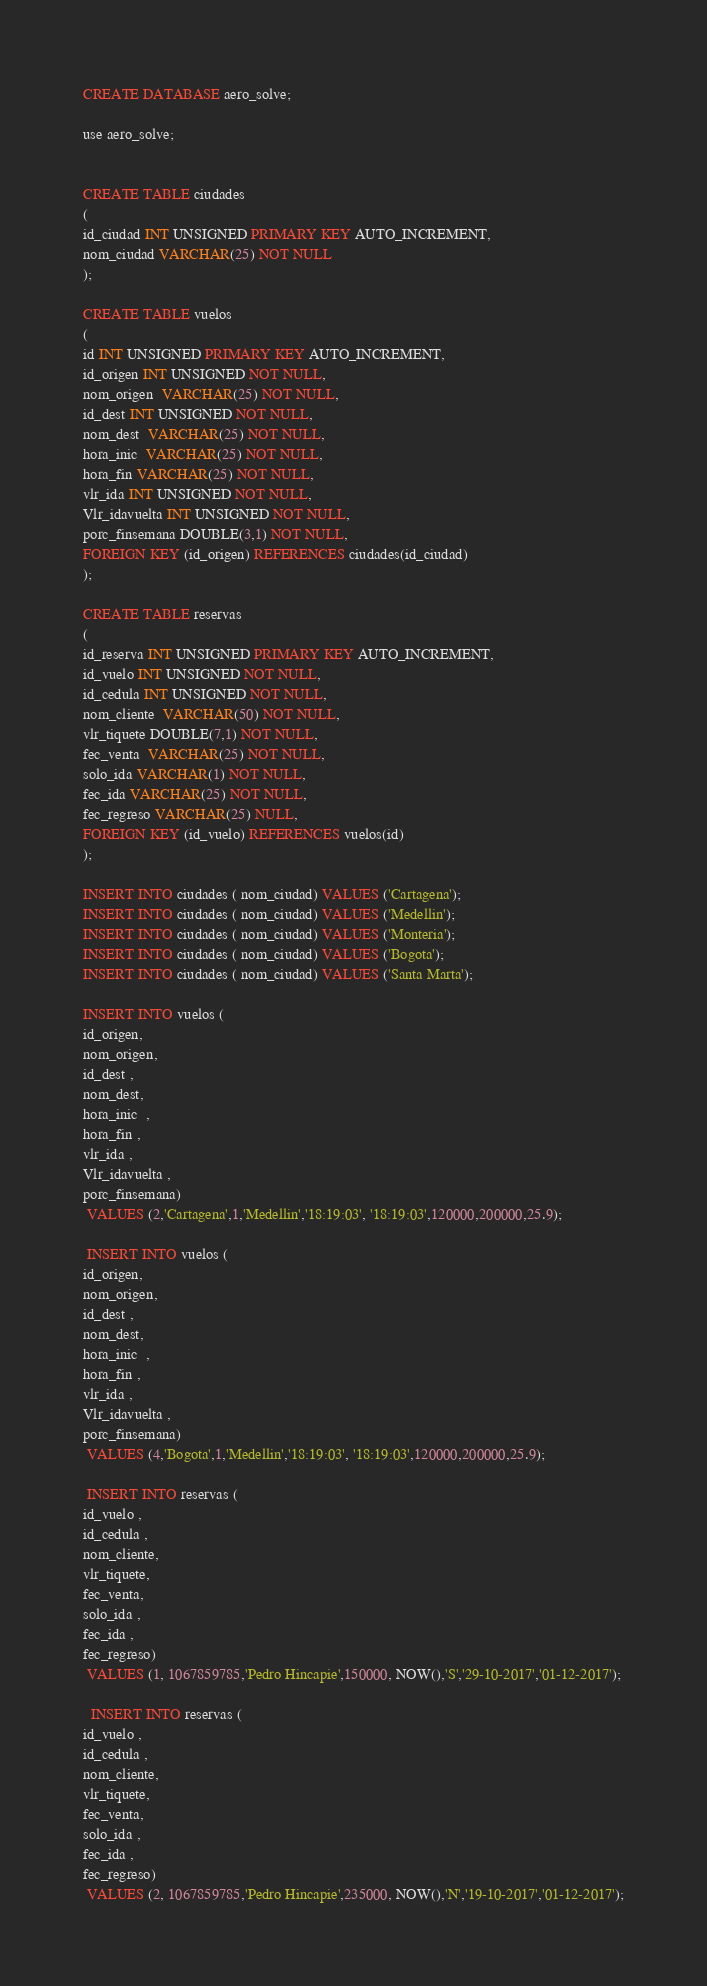Convert code to text. <code><loc_0><loc_0><loc_500><loc_500><_SQL_>CREATE DATABASE aero_solve;

use aero_solve;


CREATE TABLE ciudades
(
id_ciudad INT UNSIGNED PRIMARY KEY AUTO_INCREMENT,
nom_ciudad VARCHAR(25) NOT NULL
);

CREATE TABLE vuelos
(
id INT UNSIGNED PRIMARY KEY AUTO_INCREMENT,
id_origen INT UNSIGNED NOT NULL,
nom_origen  VARCHAR(25) NOT NULL,
id_dest INT UNSIGNED NOT NULL,
nom_dest  VARCHAR(25) NOT NULL,
hora_inic  VARCHAR(25) NOT NULL,
hora_fin VARCHAR(25) NOT NULL,
vlr_ida INT UNSIGNED NOT NULL,
Vlr_idavuelta INT UNSIGNED NOT NULL,
porc_finsemana DOUBLE(3,1) NOT NULL,
FOREIGN KEY (id_origen) REFERENCES ciudades(id_ciudad)
);

CREATE TABLE reservas
(
id_reserva INT UNSIGNED PRIMARY KEY AUTO_INCREMENT,
id_vuelo INT UNSIGNED NOT NULL,
id_cedula INT UNSIGNED NOT NULL,
nom_cliente  VARCHAR(50) NOT NULL,
vlr_tiquete DOUBLE(7,1) NOT NULL,
fec_venta  VARCHAR(25) NOT NULL,
solo_ida VARCHAR(1) NOT NULL,
fec_ida VARCHAR(25) NOT NULL,
fec_regreso VARCHAR(25) NULL,
FOREIGN KEY (id_vuelo) REFERENCES vuelos(id)
);

INSERT INTO ciudades ( nom_ciudad) VALUES ('Cartagena');
INSERT INTO ciudades ( nom_ciudad) VALUES ('Medellin');
INSERT INTO ciudades ( nom_ciudad) VALUES ('Monteria');
INSERT INTO ciudades ( nom_ciudad) VALUES ('Bogota');
INSERT INTO ciudades ( nom_ciudad) VALUES ('Santa Marta');

INSERT INTO vuelos (
id_origen,
nom_origen,
id_dest ,
nom_dest,
hora_inic  ,
hora_fin ,
vlr_ida ,
Vlr_idavuelta ,
porc_finsemana)
 VALUES (2,'Cartagena',1,'Medellin','18:19:03', '18:19:03',120000,200000,25.9);
 
 INSERT INTO vuelos (
id_origen,
nom_origen,
id_dest ,
nom_dest,
hora_inic  ,
hora_fin ,
vlr_ida ,
Vlr_idavuelta ,
porc_finsemana)
 VALUES (4,'Bogota',1,'Medellin','18:19:03', '18:19:03',120000,200000,25.9);
 
 INSERT INTO reservas (
id_vuelo ,
id_cedula ,
nom_cliente,
vlr_tiquete,
fec_venta,
solo_ida ,
fec_ida ,
fec_regreso)
 VALUES (1, 1067859785,'Pedro Hincapie',150000, NOW(),'S','29-10-2017','01-12-2017');
 
  INSERT INTO reservas (
id_vuelo ,
id_cedula ,
nom_cliente,
vlr_tiquete,
fec_venta,
solo_ida ,
fec_ida ,
fec_regreso)
 VALUES (2, 1067859785,'Pedro Hincapie',235000, NOW(),'N','19-10-2017','01-12-2017');</code> 